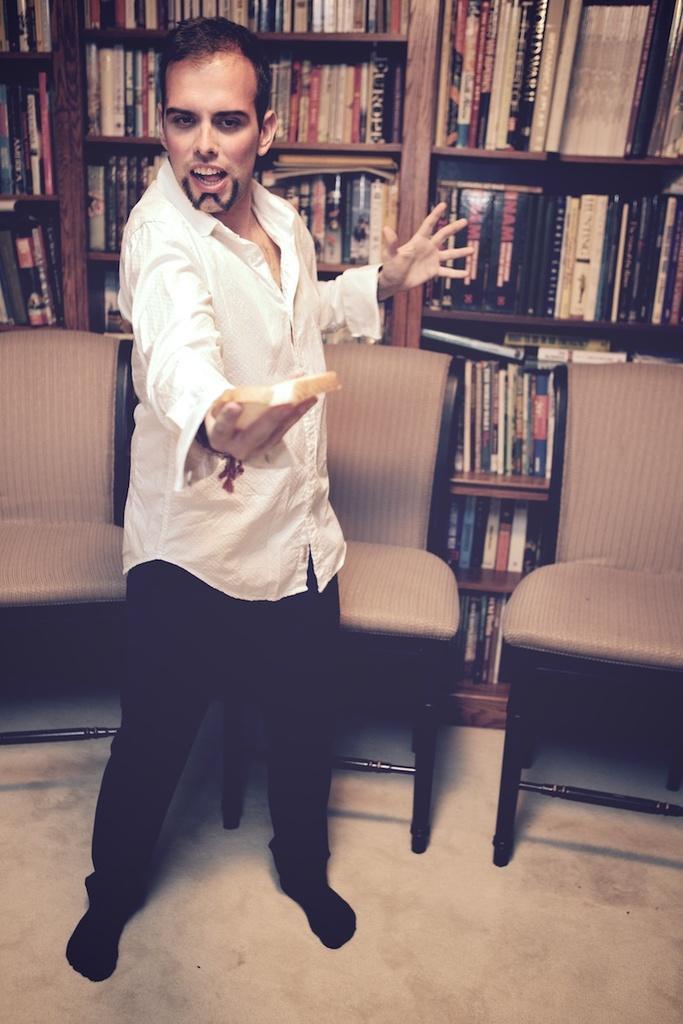Describe this image in one or two sentences. In this image there is a person wearing white color shirt standing on the floor and at the background of the image there are chairs and books in the shelves. 